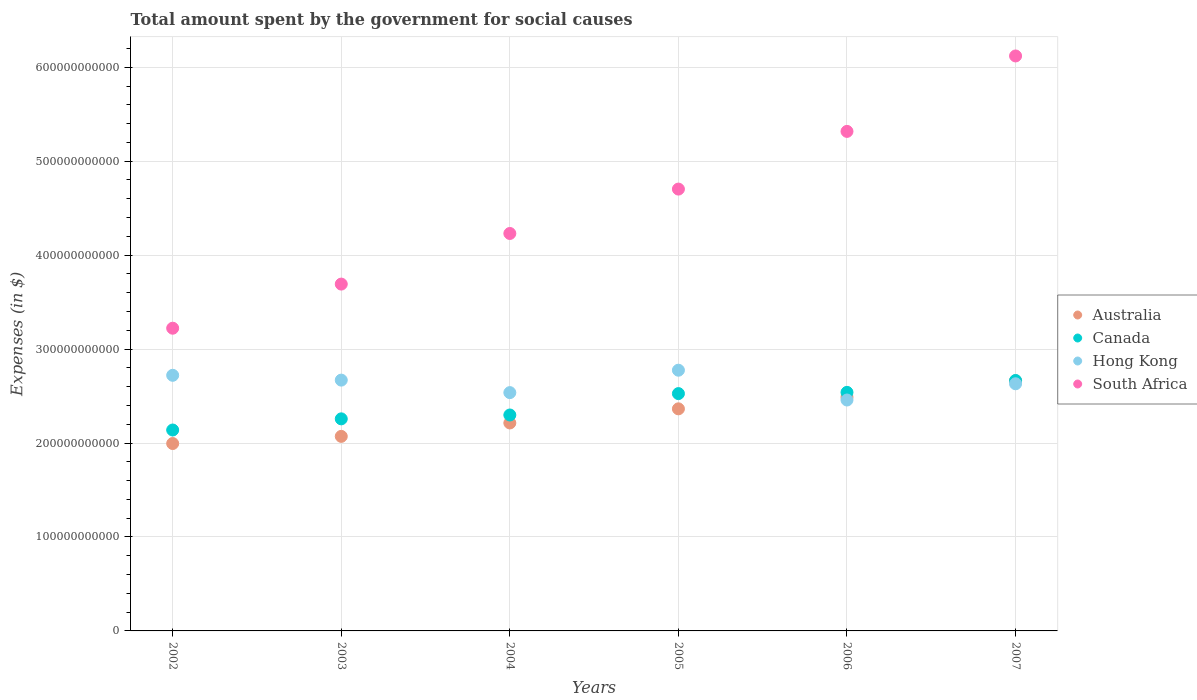How many different coloured dotlines are there?
Ensure brevity in your answer.  4. Is the number of dotlines equal to the number of legend labels?
Your answer should be compact. Yes. What is the amount spent for social causes by the government in Australia in 2007?
Offer a terse response. 2.66e+11. Across all years, what is the maximum amount spent for social causes by the government in South Africa?
Give a very brief answer. 6.12e+11. Across all years, what is the minimum amount spent for social causes by the government in Canada?
Ensure brevity in your answer.  2.14e+11. In which year was the amount spent for social causes by the government in Australia minimum?
Your answer should be very brief. 2002. What is the total amount spent for social causes by the government in South Africa in the graph?
Offer a terse response. 2.73e+12. What is the difference between the amount spent for social causes by the government in Hong Kong in 2006 and that in 2007?
Your answer should be compact. -1.73e+1. What is the difference between the amount spent for social causes by the government in South Africa in 2005 and the amount spent for social causes by the government in Australia in 2007?
Offer a very short reply. 2.04e+11. What is the average amount spent for social causes by the government in South Africa per year?
Keep it short and to the point. 4.55e+11. In the year 2007, what is the difference between the amount spent for social causes by the government in Hong Kong and amount spent for social causes by the government in South Africa?
Provide a succinct answer. -3.49e+11. In how many years, is the amount spent for social causes by the government in Hong Kong greater than 120000000000 $?
Ensure brevity in your answer.  6. What is the ratio of the amount spent for social causes by the government in South Africa in 2003 to that in 2004?
Offer a terse response. 0.87. Is the amount spent for social causes by the government in Australia in 2005 less than that in 2006?
Give a very brief answer. Yes. Is the difference between the amount spent for social causes by the government in Hong Kong in 2003 and 2005 greater than the difference between the amount spent for social causes by the government in South Africa in 2003 and 2005?
Provide a short and direct response. Yes. What is the difference between the highest and the second highest amount spent for social causes by the government in Hong Kong?
Your response must be concise. 5.43e+09. What is the difference between the highest and the lowest amount spent for social causes by the government in Hong Kong?
Your answer should be compact. 3.17e+1. In how many years, is the amount spent for social causes by the government in South Africa greater than the average amount spent for social causes by the government in South Africa taken over all years?
Provide a short and direct response. 3. Is the sum of the amount spent for social causes by the government in South Africa in 2002 and 2007 greater than the maximum amount spent for social causes by the government in Australia across all years?
Make the answer very short. Yes. How many dotlines are there?
Your answer should be compact. 4. How many years are there in the graph?
Give a very brief answer. 6. What is the difference between two consecutive major ticks on the Y-axis?
Make the answer very short. 1.00e+11. Are the values on the major ticks of Y-axis written in scientific E-notation?
Provide a short and direct response. No. Does the graph contain any zero values?
Offer a terse response. No. Does the graph contain grids?
Give a very brief answer. Yes. Where does the legend appear in the graph?
Make the answer very short. Center right. How many legend labels are there?
Your response must be concise. 4. What is the title of the graph?
Offer a terse response. Total amount spent by the government for social causes. What is the label or title of the X-axis?
Your answer should be very brief. Years. What is the label or title of the Y-axis?
Offer a very short reply. Expenses (in $). What is the Expenses (in $) in Australia in 2002?
Provide a succinct answer. 1.99e+11. What is the Expenses (in $) in Canada in 2002?
Keep it short and to the point. 2.14e+11. What is the Expenses (in $) in Hong Kong in 2002?
Keep it short and to the point. 2.72e+11. What is the Expenses (in $) in South Africa in 2002?
Your answer should be compact. 3.22e+11. What is the Expenses (in $) of Australia in 2003?
Your answer should be compact. 2.07e+11. What is the Expenses (in $) in Canada in 2003?
Your answer should be very brief. 2.26e+11. What is the Expenses (in $) in Hong Kong in 2003?
Keep it short and to the point. 2.67e+11. What is the Expenses (in $) of South Africa in 2003?
Keep it short and to the point. 3.69e+11. What is the Expenses (in $) of Australia in 2004?
Keep it short and to the point. 2.21e+11. What is the Expenses (in $) of Canada in 2004?
Your answer should be very brief. 2.30e+11. What is the Expenses (in $) of Hong Kong in 2004?
Provide a succinct answer. 2.54e+11. What is the Expenses (in $) in South Africa in 2004?
Keep it short and to the point. 4.23e+11. What is the Expenses (in $) in Australia in 2005?
Your response must be concise. 2.36e+11. What is the Expenses (in $) in Canada in 2005?
Keep it short and to the point. 2.53e+11. What is the Expenses (in $) in Hong Kong in 2005?
Make the answer very short. 2.78e+11. What is the Expenses (in $) in South Africa in 2005?
Keep it short and to the point. 4.70e+11. What is the Expenses (in $) in Australia in 2006?
Your response must be concise. 2.49e+11. What is the Expenses (in $) in Canada in 2006?
Ensure brevity in your answer.  2.54e+11. What is the Expenses (in $) of Hong Kong in 2006?
Your answer should be very brief. 2.46e+11. What is the Expenses (in $) in South Africa in 2006?
Make the answer very short. 5.32e+11. What is the Expenses (in $) in Australia in 2007?
Give a very brief answer. 2.66e+11. What is the Expenses (in $) in Canada in 2007?
Keep it short and to the point. 2.67e+11. What is the Expenses (in $) in Hong Kong in 2007?
Offer a terse response. 2.63e+11. What is the Expenses (in $) of South Africa in 2007?
Offer a very short reply. 6.12e+11. Across all years, what is the maximum Expenses (in $) of Australia?
Your answer should be very brief. 2.66e+11. Across all years, what is the maximum Expenses (in $) in Canada?
Provide a short and direct response. 2.67e+11. Across all years, what is the maximum Expenses (in $) in Hong Kong?
Your answer should be compact. 2.78e+11. Across all years, what is the maximum Expenses (in $) of South Africa?
Provide a short and direct response. 6.12e+11. Across all years, what is the minimum Expenses (in $) of Australia?
Offer a very short reply. 1.99e+11. Across all years, what is the minimum Expenses (in $) of Canada?
Offer a very short reply. 2.14e+11. Across all years, what is the minimum Expenses (in $) in Hong Kong?
Your answer should be compact. 2.46e+11. Across all years, what is the minimum Expenses (in $) of South Africa?
Ensure brevity in your answer.  3.22e+11. What is the total Expenses (in $) of Australia in the graph?
Your response must be concise. 1.38e+12. What is the total Expenses (in $) in Canada in the graph?
Offer a terse response. 1.44e+12. What is the total Expenses (in $) of Hong Kong in the graph?
Offer a terse response. 1.58e+12. What is the total Expenses (in $) in South Africa in the graph?
Make the answer very short. 2.73e+12. What is the difference between the Expenses (in $) of Australia in 2002 and that in 2003?
Your answer should be very brief. -7.62e+09. What is the difference between the Expenses (in $) in Canada in 2002 and that in 2003?
Ensure brevity in your answer.  -1.19e+1. What is the difference between the Expenses (in $) of Hong Kong in 2002 and that in 2003?
Your answer should be very brief. 5.12e+09. What is the difference between the Expenses (in $) in South Africa in 2002 and that in 2003?
Keep it short and to the point. -4.70e+1. What is the difference between the Expenses (in $) in Australia in 2002 and that in 2004?
Provide a short and direct response. -2.19e+1. What is the difference between the Expenses (in $) of Canada in 2002 and that in 2004?
Ensure brevity in your answer.  -1.60e+1. What is the difference between the Expenses (in $) in Hong Kong in 2002 and that in 2004?
Keep it short and to the point. 1.84e+1. What is the difference between the Expenses (in $) in South Africa in 2002 and that in 2004?
Your response must be concise. -1.01e+11. What is the difference between the Expenses (in $) of Australia in 2002 and that in 2005?
Provide a short and direct response. -3.69e+1. What is the difference between the Expenses (in $) in Canada in 2002 and that in 2005?
Provide a succinct answer. -3.88e+1. What is the difference between the Expenses (in $) of Hong Kong in 2002 and that in 2005?
Make the answer very short. -5.43e+09. What is the difference between the Expenses (in $) of South Africa in 2002 and that in 2005?
Make the answer very short. -1.48e+11. What is the difference between the Expenses (in $) in Australia in 2002 and that in 2006?
Provide a succinct answer. -4.94e+1. What is the difference between the Expenses (in $) of Canada in 2002 and that in 2006?
Ensure brevity in your answer.  -4.01e+1. What is the difference between the Expenses (in $) of Hong Kong in 2002 and that in 2006?
Your answer should be compact. 2.63e+1. What is the difference between the Expenses (in $) of South Africa in 2002 and that in 2006?
Provide a short and direct response. -2.10e+11. What is the difference between the Expenses (in $) of Australia in 2002 and that in 2007?
Give a very brief answer. -6.67e+1. What is the difference between the Expenses (in $) in Canada in 2002 and that in 2007?
Ensure brevity in your answer.  -5.27e+1. What is the difference between the Expenses (in $) of Hong Kong in 2002 and that in 2007?
Provide a succinct answer. 9.01e+09. What is the difference between the Expenses (in $) of South Africa in 2002 and that in 2007?
Your answer should be very brief. -2.90e+11. What is the difference between the Expenses (in $) of Australia in 2003 and that in 2004?
Give a very brief answer. -1.43e+1. What is the difference between the Expenses (in $) in Canada in 2003 and that in 2004?
Your answer should be compact. -4.11e+09. What is the difference between the Expenses (in $) in Hong Kong in 2003 and that in 2004?
Make the answer very short. 1.33e+1. What is the difference between the Expenses (in $) of South Africa in 2003 and that in 2004?
Provide a succinct answer. -5.39e+1. What is the difference between the Expenses (in $) in Australia in 2003 and that in 2005?
Offer a very short reply. -2.93e+1. What is the difference between the Expenses (in $) of Canada in 2003 and that in 2005?
Your answer should be very brief. -2.69e+1. What is the difference between the Expenses (in $) in Hong Kong in 2003 and that in 2005?
Your answer should be compact. -1.05e+1. What is the difference between the Expenses (in $) in South Africa in 2003 and that in 2005?
Give a very brief answer. -1.01e+11. What is the difference between the Expenses (in $) of Australia in 2003 and that in 2006?
Ensure brevity in your answer.  -4.17e+1. What is the difference between the Expenses (in $) of Canada in 2003 and that in 2006?
Make the answer very short. -2.82e+1. What is the difference between the Expenses (in $) of Hong Kong in 2003 and that in 2006?
Your response must be concise. 2.12e+1. What is the difference between the Expenses (in $) of South Africa in 2003 and that in 2006?
Your answer should be compact. -1.63e+11. What is the difference between the Expenses (in $) in Australia in 2003 and that in 2007?
Offer a terse response. -5.91e+1. What is the difference between the Expenses (in $) of Canada in 2003 and that in 2007?
Your answer should be compact. -4.08e+1. What is the difference between the Expenses (in $) in Hong Kong in 2003 and that in 2007?
Ensure brevity in your answer.  3.89e+09. What is the difference between the Expenses (in $) in South Africa in 2003 and that in 2007?
Your response must be concise. -2.43e+11. What is the difference between the Expenses (in $) of Australia in 2004 and that in 2005?
Your response must be concise. -1.50e+1. What is the difference between the Expenses (in $) of Canada in 2004 and that in 2005?
Give a very brief answer. -2.28e+1. What is the difference between the Expenses (in $) of Hong Kong in 2004 and that in 2005?
Provide a succinct answer. -2.39e+1. What is the difference between the Expenses (in $) in South Africa in 2004 and that in 2005?
Your response must be concise. -4.72e+1. What is the difference between the Expenses (in $) in Australia in 2004 and that in 2006?
Keep it short and to the point. -2.75e+1. What is the difference between the Expenses (in $) of Canada in 2004 and that in 2006?
Your answer should be very brief. -2.41e+1. What is the difference between the Expenses (in $) in Hong Kong in 2004 and that in 2006?
Provide a succinct answer. 7.87e+09. What is the difference between the Expenses (in $) of South Africa in 2004 and that in 2006?
Provide a short and direct response. -1.09e+11. What is the difference between the Expenses (in $) in Australia in 2004 and that in 2007?
Offer a terse response. -4.48e+1. What is the difference between the Expenses (in $) of Canada in 2004 and that in 2007?
Your answer should be very brief. -3.67e+1. What is the difference between the Expenses (in $) of Hong Kong in 2004 and that in 2007?
Provide a succinct answer. -9.41e+09. What is the difference between the Expenses (in $) of South Africa in 2004 and that in 2007?
Keep it short and to the point. -1.89e+11. What is the difference between the Expenses (in $) of Australia in 2005 and that in 2006?
Ensure brevity in your answer.  -1.24e+1. What is the difference between the Expenses (in $) in Canada in 2005 and that in 2006?
Give a very brief answer. -1.32e+09. What is the difference between the Expenses (in $) in Hong Kong in 2005 and that in 2006?
Keep it short and to the point. 3.17e+1. What is the difference between the Expenses (in $) of South Africa in 2005 and that in 2006?
Provide a short and direct response. -6.14e+1. What is the difference between the Expenses (in $) of Australia in 2005 and that in 2007?
Give a very brief answer. -2.98e+1. What is the difference between the Expenses (in $) of Canada in 2005 and that in 2007?
Make the answer very short. -1.40e+1. What is the difference between the Expenses (in $) of Hong Kong in 2005 and that in 2007?
Provide a short and direct response. 1.44e+1. What is the difference between the Expenses (in $) of South Africa in 2005 and that in 2007?
Keep it short and to the point. -1.42e+11. What is the difference between the Expenses (in $) of Australia in 2006 and that in 2007?
Give a very brief answer. -1.74e+1. What is the difference between the Expenses (in $) of Canada in 2006 and that in 2007?
Keep it short and to the point. -1.26e+1. What is the difference between the Expenses (in $) of Hong Kong in 2006 and that in 2007?
Keep it short and to the point. -1.73e+1. What is the difference between the Expenses (in $) of South Africa in 2006 and that in 2007?
Offer a very short reply. -8.03e+1. What is the difference between the Expenses (in $) of Australia in 2002 and the Expenses (in $) of Canada in 2003?
Offer a very short reply. -2.63e+1. What is the difference between the Expenses (in $) of Australia in 2002 and the Expenses (in $) of Hong Kong in 2003?
Offer a very short reply. -6.75e+1. What is the difference between the Expenses (in $) in Australia in 2002 and the Expenses (in $) in South Africa in 2003?
Your answer should be compact. -1.70e+11. What is the difference between the Expenses (in $) in Canada in 2002 and the Expenses (in $) in Hong Kong in 2003?
Keep it short and to the point. -5.31e+1. What is the difference between the Expenses (in $) of Canada in 2002 and the Expenses (in $) of South Africa in 2003?
Offer a very short reply. -1.55e+11. What is the difference between the Expenses (in $) of Hong Kong in 2002 and the Expenses (in $) of South Africa in 2003?
Your answer should be very brief. -9.71e+1. What is the difference between the Expenses (in $) in Australia in 2002 and the Expenses (in $) in Canada in 2004?
Offer a terse response. -3.04e+1. What is the difference between the Expenses (in $) of Australia in 2002 and the Expenses (in $) of Hong Kong in 2004?
Offer a terse response. -5.42e+1. What is the difference between the Expenses (in $) in Australia in 2002 and the Expenses (in $) in South Africa in 2004?
Ensure brevity in your answer.  -2.24e+11. What is the difference between the Expenses (in $) in Canada in 2002 and the Expenses (in $) in Hong Kong in 2004?
Offer a terse response. -3.98e+1. What is the difference between the Expenses (in $) of Canada in 2002 and the Expenses (in $) of South Africa in 2004?
Offer a terse response. -2.09e+11. What is the difference between the Expenses (in $) in Hong Kong in 2002 and the Expenses (in $) in South Africa in 2004?
Give a very brief answer. -1.51e+11. What is the difference between the Expenses (in $) of Australia in 2002 and the Expenses (in $) of Canada in 2005?
Provide a succinct answer. -5.31e+1. What is the difference between the Expenses (in $) in Australia in 2002 and the Expenses (in $) in Hong Kong in 2005?
Your answer should be very brief. -7.81e+1. What is the difference between the Expenses (in $) of Australia in 2002 and the Expenses (in $) of South Africa in 2005?
Provide a short and direct response. -2.71e+11. What is the difference between the Expenses (in $) of Canada in 2002 and the Expenses (in $) of Hong Kong in 2005?
Offer a very short reply. -6.37e+1. What is the difference between the Expenses (in $) in Canada in 2002 and the Expenses (in $) in South Africa in 2005?
Ensure brevity in your answer.  -2.56e+11. What is the difference between the Expenses (in $) in Hong Kong in 2002 and the Expenses (in $) in South Africa in 2005?
Make the answer very short. -1.98e+11. What is the difference between the Expenses (in $) of Australia in 2002 and the Expenses (in $) of Canada in 2006?
Your answer should be very brief. -5.45e+1. What is the difference between the Expenses (in $) of Australia in 2002 and the Expenses (in $) of Hong Kong in 2006?
Provide a succinct answer. -4.63e+1. What is the difference between the Expenses (in $) in Australia in 2002 and the Expenses (in $) in South Africa in 2006?
Provide a short and direct response. -3.32e+11. What is the difference between the Expenses (in $) in Canada in 2002 and the Expenses (in $) in Hong Kong in 2006?
Your answer should be compact. -3.19e+1. What is the difference between the Expenses (in $) of Canada in 2002 and the Expenses (in $) of South Africa in 2006?
Your answer should be very brief. -3.18e+11. What is the difference between the Expenses (in $) of Hong Kong in 2002 and the Expenses (in $) of South Africa in 2006?
Make the answer very short. -2.60e+11. What is the difference between the Expenses (in $) of Australia in 2002 and the Expenses (in $) of Canada in 2007?
Provide a succinct answer. -6.71e+1. What is the difference between the Expenses (in $) in Australia in 2002 and the Expenses (in $) in Hong Kong in 2007?
Your response must be concise. -6.36e+1. What is the difference between the Expenses (in $) of Australia in 2002 and the Expenses (in $) of South Africa in 2007?
Keep it short and to the point. -4.13e+11. What is the difference between the Expenses (in $) of Canada in 2002 and the Expenses (in $) of Hong Kong in 2007?
Ensure brevity in your answer.  -4.92e+1. What is the difference between the Expenses (in $) in Canada in 2002 and the Expenses (in $) in South Africa in 2007?
Provide a short and direct response. -3.98e+11. What is the difference between the Expenses (in $) of Hong Kong in 2002 and the Expenses (in $) of South Africa in 2007?
Offer a very short reply. -3.40e+11. What is the difference between the Expenses (in $) of Australia in 2003 and the Expenses (in $) of Canada in 2004?
Provide a succinct answer. -2.28e+1. What is the difference between the Expenses (in $) in Australia in 2003 and the Expenses (in $) in Hong Kong in 2004?
Your answer should be very brief. -4.66e+1. What is the difference between the Expenses (in $) in Australia in 2003 and the Expenses (in $) in South Africa in 2004?
Give a very brief answer. -2.16e+11. What is the difference between the Expenses (in $) of Canada in 2003 and the Expenses (in $) of Hong Kong in 2004?
Provide a succinct answer. -2.79e+1. What is the difference between the Expenses (in $) in Canada in 2003 and the Expenses (in $) in South Africa in 2004?
Provide a succinct answer. -1.97e+11. What is the difference between the Expenses (in $) of Hong Kong in 2003 and the Expenses (in $) of South Africa in 2004?
Ensure brevity in your answer.  -1.56e+11. What is the difference between the Expenses (in $) in Australia in 2003 and the Expenses (in $) in Canada in 2005?
Make the answer very short. -4.55e+1. What is the difference between the Expenses (in $) in Australia in 2003 and the Expenses (in $) in Hong Kong in 2005?
Your answer should be compact. -7.04e+1. What is the difference between the Expenses (in $) of Australia in 2003 and the Expenses (in $) of South Africa in 2005?
Your answer should be compact. -2.63e+11. What is the difference between the Expenses (in $) of Canada in 2003 and the Expenses (in $) of Hong Kong in 2005?
Give a very brief answer. -5.18e+1. What is the difference between the Expenses (in $) of Canada in 2003 and the Expenses (in $) of South Africa in 2005?
Provide a short and direct response. -2.45e+11. What is the difference between the Expenses (in $) in Hong Kong in 2003 and the Expenses (in $) in South Africa in 2005?
Provide a short and direct response. -2.03e+11. What is the difference between the Expenses (in $) in Australia in 2003 and the Expenses (in $) in Canada in 2006?
Your answer should be compact. -4.68e+1. What is the difference between the Expenses (in $) of Australia in 2003 and the Expenses (in $) of Hong Kong in 2006?
Provide a succinct answer. -3.87e+1. What is the difference between the Expenses (in $) of Australia in 2003 and the Expenses (in $) of South Africa in 2006?
Keep it short and to the point. -3.25e+11. What is the difference between the Expenses (in $) in Canada in 2003 and the Expenses (in $) in Hong Kong in 2006?
Provide a succinct answer. -2.01e+1. What is the difference between the Expenses (in $) in Canada in 2003 and the Expenses (in $) in South Africa in 2006?
Provide a short and direct response. -3.06e+11. What is the difference between the Expenses (in $) in Hong Kong in 2003 and the Expenses (in $) in South Africa in 2006?
Keep it short and to the point. -2.65e+11. What is the difference between the Expenses (in $) in Australia in 2003 and the Expenses (in $) in Canada in 2007?
Give a very brief answer. -5.95e+1. What is the difference between the Expenses (in $) in Australia in 2003 and the Expenses (in $) in Hong Kong in 2007?
Provide a succinct answer. -5.60e+1. What is the difference between the Expenses (in $) of Australia in 2003 and the Expenses (in $) of South Africa in 2007?
Give a very brief answer. -4.05e+11. What is the difference between the Expenses (in $) in Canada in 2003 and the Expenses (in $) in Hong Kong in 2007?
Your answer should be very brief. -3.73e+1. What is the difference between the Expenses (in $) in Canada in 2003 and the Expenses (in $) in South Africa in 2007?
Your answer should be very brief. -3.86e+11. What is the difference between the Expenses (in $) of Hong Kong in 2003 and the Expenses (in $) of South Africa in 2007?
Your answer should be very brief. -3.45e+11. What is the difference between the Expenses (in $) of Australia in 2004 and the Expenses (in $) of Canada in 2005?
Your answer should be very brief. -3.13e+1. What is the difference between the Expenses (in $) of Australia in 2004 and the Expenses (in $) of Hong Kong in 2005?
Provide a short and direct response. -5.62e+1. What is the difference between the Expenses (in $) of Australia in 2004 and the Expenses (in $) of South Africa in 2005?
Your response must be concise. -2.49e+11. What is the difference between the Expenses (in $) in Canada in 2004 and the Expenses (in $) in Hong Kong in 2005?
Provide a short and direct response. -4.77e+1. What is the difference between the Expenses (in $) of Canada in 2004 and the Expenses (in $) of South Africa in 2005?
Keep it short and to the point. -2.40e+11. What is the difference between the Expenses (in $) in Hong Kong in 2004 and the Expenses (in $) in South Africa in 2005?
Offer a very short reply. -2.17e+11. What is the difference between the Expenses (in $) of Australia in 2004 and the Expenses (in $) of Canada in 2006?
Make the answer very short. -3.26e+1. What is the difference between the Expenses (in $) in Australia in 2004 and the Expenses (in $) in Hong Kong in 2006?
Ensure brevity in your answer.  -2.44e+1. What is the difference between the Expenses (in $) of Australia in 2004 and the Expenses (in $) of South Africa in 2006?
Give a very brief answer. -3.10e+11. What is the difference between the Expenses (in $) of Canada in 2004 and the Expenses (in $) of Hong Kong in 2006?
Provide a short and direct response. -1.59e+1. What is the difference between the Expenses (in $) in Canada in 2004 and the Expenses (in $) in South Africa in 2006?
Make the answer very short. -3.02e+11. What is the difference between the Expenses (in $) of Hong Kong in 2004 and the Expenses (in $) of South Africa in 2006?
Offer a very short reply. -2.78e+11. What is the difference between the Expenses (in $) of Australia in 2004 and the Expenses (in $) of Canada in 2007?
Offer a terse response. -4.52e+1. What is the difference between the Expenses (in $) of Australia in 2004 and the Expenses (in $) of Hong Kong in 2007?
Provide a short and direct response. -4.17e+1. What is the difference between the Expenses (in $) in Australia in 2004 and the Expenses (in $) in South Africa in 2007?
Your answer should be very brief. -3.91e+11. What is the difference between the Expenses (in $) in Canada in 2004 and the Expenses (in $) in Hong Kong in 2007?
Provide a succinct answer. -3.32e+1. What is the difference between the Expenses (in $) of Canada in 2004 and the Expenses (in $) of South Africa in 2007?
Give a very brief answer. -3.82e+11. What is the difference between the Expenses (in $) in Hong Kong in 2004 and the Expenses (in $) in South Africa in 2007?
Offer a very short reply. -3.58e+11. What is the difference between the Expenses (in $) of Australia in 2005 and the Expenses (in $) of Canada in 2006?
Provide a succinct answer. -1.75e+1. What is the difference between the Expenses (in $) in Australia in 2005 and the Expenses (in $) in Hong Kong in 2006?
Your answer should be compact. -9.39e+09. What is the difference between the Expenses (in $) of Australia in 2005 and the Expenses (in $) of South Africa in 2006?
Provide a short and direct response. -2.95e+11. What is the difference between the Expenses (in $) of Canada in 2005 and the Expenses (in $) of Hong Kong in 2006?
Give a very brief answer. 6.83e+09. What is the difference between the Expenses (in $) of Canada in 2005 and the Expenses (in $) of South Africa in 2006?
Offer a terse response. -2.79e+11. What is the difference between the Expenses (in $) of Hong Kong in 2005 and the Expenses (in $) of South Africa in 2006?
Your answer should be very brief. -2.54e+11. What is the difference between the Expenses (in $) in Australia in 2005 and the Expenses (in $) in Canada in 2007?
Offer a terse response. -3.02e+1. What is the difference between the Expenses (in $) in Australia in 2005 and the Expenses (in $) in Hong Kong in 2007?
Give a very brief answer. -2.67e+1. What is the difference between the Expenses (in $) of Australia in 2005 and the Expenses (in $) of South Africa in 2007?
Offer a very short reply. -3.76e+11. What is the difference between the Expenses (in $) in Canada in 2005 and the Expenses (in $) in Hong Kong in 2007?
Provide a succinct answer. -1.05e+1. What is the difference between the Expenses (in $) in Canada in 2005 and the Expenses (in $) in South Africa in 2007?
Your answer should be compact. -3.59e+11. What is the difference between the Expenses (in $) of Hong Kong in 2005 and the Expenses (in $) of South Africa in 2007?
Offer a terse response. -3.35e+11. What is the difference between the Expenses (in $) of Australia in 2006 and the Expenses (in $) of Canada in 2007?
Your answer should be very brief. -1.78e+1. What is the difference between the Expenses (in $) of Australia in 2006 and the Expenses (in $) of Hong Kong in 2007?
Offer a very short reply. -1.43e+1. What is the difference between the Expenses (in $) in Australia in 2006 and the Expenses (in $) in South Africa in 2007?
Your answer should be compact. -3.63e+11. What is the difference between the Expenses (in $) in Canada in 2006 and the Expenses (in $) in Hong Kong in 2007?
Offer a terse response. -9.14e+09. What is the difference between the Expenses (in $) in Canada in 2006 and the Expenses (in $) in South Africa in 2007?
Your response must be concise. -3.58e+11. What is the difference between the Expenses (in $) in Hong Kong in 2006 and the Expenses (in $) in South Africa in 2007?
Keep it short and to the point. -3.66e+11. What is the average Expenses (in $) in Australia per year?
Offer a terse response. 2.30e+11. What is the average Expenses (in $) of Canada per year?
Provide a short and direct response. 2.40e+11. What is the average Expenses (in $) in Hong Kong per year?
Offer a very short reply. 2.63e+11. What is the average Expenses (in $) of South Africa per year?
Give a very brief answer. 4.55e+11. In the year 2002, what is the difference between the Expenses (in $) of Australia and Expenses (in $) of Canada?
Offer a very short reply. -1.44e+1. In the year 2002, what is the difference between the Expenses (in $) of Australia and Expenses (in $) of Hong Kong?
Ensure brevity in your answer.  -7.26e+1. In the year 2002, what is the difference between the Expenses (in $) of Australia and Expenses (in $) of South Africa?
Your answer should be very brief. -1.23e+11. In the year 2002, what is the difference between the Expenses (in $) in Canada and Expenses (in $) in Hong Kong?
Give a very brief answer. -5.82e+1. In the year 2002, what is the difference between the Expenses (in $) in Canada and Expenses (in $) in South Africa?
Keep it short and to the point. -1.08e+11. In the year 2002, what is the difference between the Expenses (in $) in Hong Kong and Expenses (in $) in South Africa?
Your answer should be compact. -5.01e+1. In the year 2003, what is the difference between the Expenses (in $) in Australia and Expenses (in $) in Canada?
Provide a succinct answer. -1.87e+1. In the year 2003, what is the difference between the Expenses (in $) of Australia and Expenses (in $) of Hong Kong?
Your response must be concise. -5.99e+1. In the year 2003, what is the difference between the Expenses (in $) of Australia and Expenses (in $) of South Africa?
Your answer should be compact. -1.62e+11. In the year 2003, what is the difference between the Expenses (in $) of Canada and Expenses (in $) of Hong Kong?
Provide a succinct answer. -4.12e+1. In the year 2003, what is the difference between the Expenses (in $) of Canada and Expenses (in $) of South Africa?
Offer a terse response. -1.43e+11. In the year 2003, what is the difference between the Expenses (in $) in Hong Kong and Expenses (in $) in South Africa?
Keep it short and to the point. -1.02e+11. In the year 2004, what is the difference between the Expenses (in $) in Australia and Expenses (in $) in Canada?
Make the answer very short. -8.48e+09. In the year 2004, what is the difference between the Expenses (in $) of Australia and Expenses (in $) of Hong Kong?
Give a very brief answer. -3.23e+1. In the year 2004, what is the difference between the Expenses (in $) in Australia and Expenses (in $) in South Africa?
Make the answer very short. -2.02e+11. In the year 2004, what is the difference between the Expenses (in $) in Canada and Expenses (in $) in Hong Kong?
Your answer should be very brief. -2.38e+1. In the year 2004, what is the difference between the Expenses (in $) in Canada and Expenses (in $) in South Africa?
Give a very brief answer. -1.93e+11. In the year 2004, what is the difference between the Expenses (in $) in Hong Kong and Expenses (in $) in South Africa?
Ensure brevity in your answer.  -1.69e+11. In the year 2005, what is the difference between the Expenses (in $) of Australia and Expenses (in $) of Canada?
Provide a succinct answer. -1.62e+1. In the year 2005, what is the difference between the Expenses (in $) in Australia and Expenses (in $) in Hong Kong?
Make the answer very short. -4.11e+1. In the year 2005, what is the difference between the Expenses (in $) of Australia and Expenses (in $) of South Africa?
Your response must be concise. -2.34e+11. In the year 2005, what is the difference between the Expenses (in $) of Canada and Expenses (in $) of Hong Kong?
Offer a terse response. -2.49e+1. In the year 2005, what is the difference between the Expenses (in $) in Canada and Expenses (in $) in South Africa?
Offer a terse response. -2.18e+11. In the year 2005, what is the difference between the Expenses (in $) in Hong Kong and Expenses (in $) in South Africa?
Ensure brevity in your answer.  -1.93e+11. In the year 2006, what is the difference between the Expenses (in $) of Australia and Expenses (in $) of Canada?
Make the answer very short. -5.11e+09. In the year 2006, what is the difference between the Expenses (in $) in Australia and Expenses (in $) in Hong Kong?
Keep it short and to the point. 3.04e+09. In the year 2006, what is the difference between the Expenses (in $) of Australia and Expenses (in $) of South Africa?
Provide a short and direct response. -2.83e+11. In the year 2006, what is the difference between the Expenses (in $) in Canada and Expenses (in $) in Hong Kong?
Provide a short and direct response. 8.14e+09. In the year 2006, what is the difference between the Expenses (in $) in Canada and Expenses (in $) in South Africa?
Give a very brief answer. -2.78e+11. In the year 2006, what is the difference between the Expenses (in $) of Hong Kong and Expenses (in $) of South Africa?
Ensure brevity in your answer.  -2.86e+11. In the year 2007, what is the difference between the Expenses (in $) in Australia and Expenses (in $) in Canada?
Your response must be concise. -3.83e+08. In the year 2007, what is the difference between the Expenses (in $) of Australia and Expenses (in $) of Hong Kong?
Provide a succinct answer. 3.12e+09. In the year 2007, what is the difference between the Expenses (in $) in Australia and Expenses (in $) in South Africa?
Ensure brevity in your answer.  -3.46e+11. In the year 2007, what is the difference between the Expenses (in $) of Canada and Expenses (in $) of Hong Kong?
Offer a terse response. 3.50e+09. In the year 2007, what is the difference between the Expenses (in $) of Canada and Expenses (in $) of South Africa?
Provide a succinct answer. -3.45e+11. In the year 2007, what is the difference between the Expenses (in $) in Hong Kong and Expenses (in $) in South Africa?
Your response must be concise. -3.49e+11. What is the ratio of the Expenses (in $) of Australia in 2002 to that in 2003?
Provide a short and direct response. 0.96. What is the ratio of the Expenses (in $) of Canada in 2002 to that in 2003?
Provide a short and direct response. 0.95. What is the ratio of the Expenses (in $) in Hong Kong in 2002 to that in 2003?
Your answer should be very brief. 1.02. What is the ratio of the Expenses (in $) in South Africa in 2002 to that in 2003?
Your answer should be very brief. 0.87. What is the ratio of the Expenses (in $) of Australia in 2002 to that in 2004?
Offer a terse response. 0.9. What is the ratio of the Expenses (in $) in Canada in 2002 to that in 2004?
Provide a short and direct response. 0.93. What is the ratio of the Expenses (in $) in Hong Kong in 2002 to that in 2004?
Your answer should be very brief. 1.07. What is the ratio of the Expenses (in $) in South Africa in 2002 to that in 2004?
Provide a short and direct response. 0.76. What is the ratio of the Expenses (in $) of Australia in 2002 to that in 2005?
Offer a very short reply. 0.84. What is the ratio of the Expenses (in $) of Canada in 2002 to that in 2005?
Make the answer very short. 0.85. What is the ratio of the Expenses (in $) of Hong Kong in 2002 to that in 2005?
Provide a short and direct response. 0.98. What is the ratio of the Expenses (in $) of South Africa in 2002 to that in 2005?
Keep it short and to the point. 0.69. What is the ratio of the Expenses (in $) in Australia in 2002 to that in 2006?
Offer a very short reply. 0.8. What is the ratio of the Expenses (in $) of Canada in 2002 to that in 2006?
Your answer should be compact. 0.84. What is the ratio of the Expenses (in $) of Hong Kong in 2002 to that in 2006?
Provide a succinct answer. 1.11. What is the ratio of the Expenses (in $) of South Africa in 2002 to that in 2006?
Your answer should be compact. 0.61. What is the ratio of the Expenses (in $) of Australia in 2002 to that in 2007?
Your answer should be compact. 0.75. What is the ratio of the Expenses (in $) in Canada in 2002 to that in 2007?
Offer a very short reply. 0.8. What is the ratio of the Expenses (in $) in Hong Kong in 2002 to that in 2007?
Your response must be concise. 1.03. What is the ratio of the Expenses (in $) of South Africa in 2002 to that in 2007?
Keep it short and to the point. 0.53. What is the ratio of the Expenses (in $) in Australia in 2003 to that in 2004?
Your response must be concise. 0.94. What is the ratio of the Expenses (in $) of Canada in 2003 to that in 2004?
Your answer should be compact. 0.98. What is the ratio of the Expenses (in $) in Hong Kong in 2003 to that in 2004?
Your answer should be compact. 1.05. What is the ratio of the Expenses (in $) of South Africa in 2003 to that in 2004?
Your answer should be very brief. 0.87. What is the ratio of the Expenses (in $) in Australia in 2003 to that in 2005?
Offer a terse response. 0.88. What is the ratio of the Expenses (in $) of Canada in 2003 to that in 2005?
Your response must be concise. 0.89. What is the ratio of the Expenses (in $) in South Africa in 2003 to that in 2005?
Ensure brevity in your answer.  0.79. What is the ratio of the Expenses (in $) of Australia in 2003 to that in 2006?
Offer a terse response. 0.83. What is the ratio of the Expenses (in $) in Canada in 2003 to that in 2006?
Provide a short and direct response. 0.89. What is the ratio of the Expenses (in $) in Hong Kong in 2003 to that in 2006?
Your answer should be compact. 1.09. What is the ratio of the Expenses (in $) in South Africa in 2003 to that in 2006?
Your answer should be compact. 0.69. What is the ratio of the Expenses (in $) of Australia in 2003 to that in 2007?
Your answer should be compact. 0.78. What is the ratio of the Expenses (in $) in Canada in 2003 to that in 2007?
Provide a short and direct response. 0.85. What is the ratio of the Expenses (in $) of Hong Kong in 2003 to that in 2007?
Provide a short and direct response. 1.01. What is the ratio of the Expenses (in $) of South Africa in 2003 to that in 2007?
Offer a very short reply. 0.6. What is the ratio of the Expenses (in $) of Australia in 2004 to that in 2005?
Provide a succinct answer. 0.94. What is the ratio of the Expenses (in $) of Canada in 2004 to that in 2005?
Provide a succinct answer. 0.91. What is the ratio of the Expenses (in $) of Hong Kong in 2004 to that in 2005?
Your answer should be compact. 0.91. What is the ratio of the Expenses (in $) in South Africa in 2004 to that in 2005?
Offer a terse response. 0.9. What is the ratio of the Expenses (in $) in Australia in 2004 to that in 2006?
Offer a very short reply. 0.89. What is the ratio of the Expenses (in $) of Canada in 2004 to that in 2006?
Make the answer very short. 0.91. What is the ratio of the Expenses (in $) in Hong Kong in 2004 to that in 2006?
Provide a short and direct response. 1.03. What is the ratio of the Expenses (in $) in South Africa in 2004 to that in 2006?
Your answer should be compact. 0.8. What is the ratio of the Expenses (in $) in Australia in 2004 to that in 2007?
Keep it short and to the point. 0.83. What is the ratio of the Expenses (in $) of Canada in 2004 to that in 2007?
Offer a very short reply. 0.86. What is the ratio of the Expenses (in $) in Hong Kong in 2004 to that in 2007?
Provide a succinct answer. 0.96. What is the ratio of the Expenses (in $) in South Africa in 2004 to that in 2007?
Your response must be concise. 0.69. What is the ratio of the Expenses (in $) in Australia in 2005 to that in 2006?
Give a very brief answer. 0.95. What is the ratio of the Expenses (in $) in Canada in 2005 to that in 2006?
Offer a very short reply. 0.99. What is the ratio of the Expenses (in $) in Hong Kong in 2005 to that in 2006?
Provide a succinct answer. 1.13. What is the ratio of the Expenses (in $) in South Africa in 2005 to that in 2006?
Provide a short and direct response. 0.88. What is the ratio of the Expenses (in $) of Australia in 2005 to that in 2007?
Ensure brevity in your answer.  0.89. What is the ratio of the Expenses (in $) of Canada in 2005 to that in 2007?
Provide a short and direct response. 0.95. What is the ratio of the Expenses (in $) of Hong Kong in 2005 to that in 2007?
Provide a succinct answer. 1.05. What is the ratio of the Expenses (in $) in South Africa in 2005 to that in 2007?
Keep it short and to the point. 0.77. What is the ratio of the Expenses (in $) of Australia in 2006 to that in 2007?
Your response must be concise. 0.93. What is the ratio of the Expenses (in $) in Canada in 2006 to that in 2007?
Provide a short and direct response. 0.95. What is the ratio of the Expenses (in $) of Hong Kong in 2006 to that in 2007?
Give a very brief answer. 0.93. What is the ratio of the Expenses (in $) of South Africa in 2006 to that in 2007?
Your answer should be very brief. 0.87. What is the difference between the highest and the second highest Expenses (in $) of Australia?
Give a very brief answer. 1.74e+1. What is the difference between the highest and the second highest Expenses (in $) in Canada?
Your response must be concise. 1.26e+1. What is the difference between the highest and the second highest Expenses (in $) in Hong Kong?
Your response must be concise. 5.43e+09. What is the difference between the highest and the second highest Expenses (in $) of South Africa?
Give a very brief answer. 8.03e+1. What is the difference between the highest and the lowest Expenses (in $) of Australia?
Make the answer very short. 6.67e+1. What is the difference between the highest and the lowest Expenses (in $) of Canada?
Ensure brevity in your answer.  5.27e+1. What is the difference between the highest and the lowest Expenses (in $) in Hong Kong?
Your answer should be very brief. 3.17e+1. What is the difference between the highest and the lowest Expenses (in $) in South Africa?
Provide a short and direct response. 2.90e+11. 